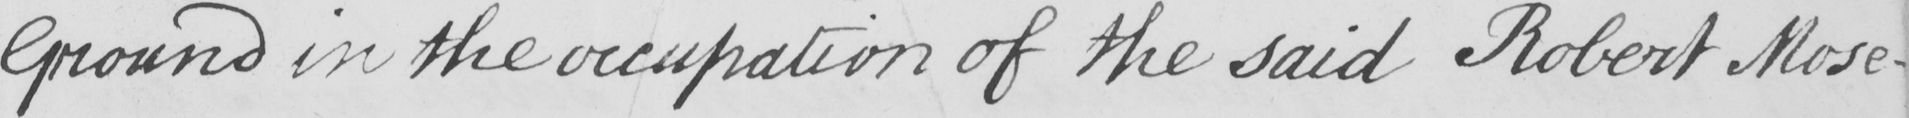Can you tell me what this handwritten text says? Ground in the occupation of the said Robert Mose- 